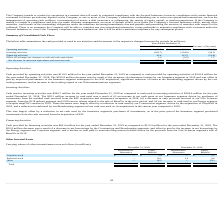According to Hc2 Holdings's financial document, What is the cash provided by operating activities in 2019? According to the financial document, $110.5 million. The relevant text states: "Cash provided by operating activities was $110.5 million for the year ended December 31, 2019 as compared to cash provided by operating activities of $341.4..." Also, What is the cash provided by financing activities in 2019? According to the financial document, $62.4 million. The relevant text states: "Cash provided by financing activities was $62.4 million for the year ended December 31, 2019 as compared to $115.2 million for the year ended December 31, 2..." Also, What was the cash used in investing activities in 2019? According to the financial document, (263.7) (in millions). The relevant text states: "Investing activities (263.7) (224.6) (39.1)..." Also, can you calculate: What is the percentage change in the cash provided by operating activities from 2018 to 2019? To answer this question, I need to perform calculations using the financial data. The calculation is: 110.5 / 341.4 - 1, which equals -67.63 (percentage). This is based on the information: "Operating activities $ 110.5 $ 341.4 $ (230.9) Operating activities $ 110.5 $ 341.4 $ (230.9)..." The key data points involved are: 110.5, 341.4. Also, can you calculate: What is the average cash used in investing activities for 2018 and 2019? To answer this question, I need to perform calculations using the financial data. The calculation is: -(263.7 + 224.6) / 2, which equals -244.15 (in millions). This is based on the information: "Investing activities (263.7) (224.6) (39.1) Investing activities (263.7) (224.6) (39.1)..." The key data points involved are: 224.6, 263.7. Also, can you calculate: What is the average cash provided by financing activities? To answer this question, I need to perform calculations using the financial data. The calculation is: (62.4 + 115.2) / 2, which equals 88.8 (in millions). This is based on the information: "Financing activities 62.4 115.2 (52.8) Financing activities 62.4 115.2 (52.8)..." The key data points involved are: 115.2, 62.4. 